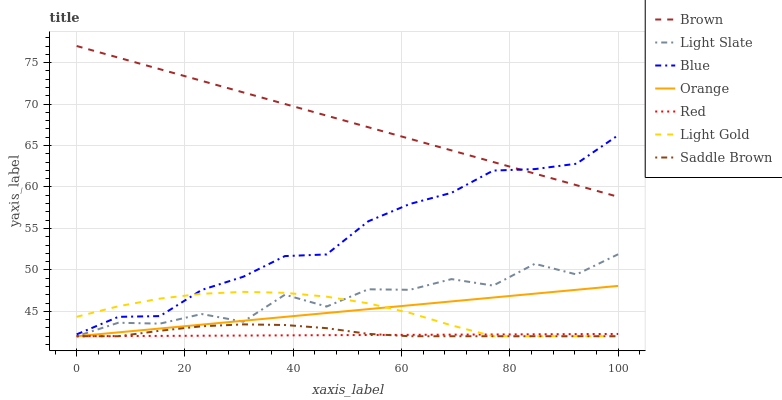Does Light Slate have the minimum area under the curve?
Answer yes or no. No. Does Light Slate have the maximum area under the curve?
Answer yes or no. No. Is Brown the smoothest?
Answer yes or no. No. Is Brown the roughest?
Answer yes or no. No. Does Brown have the lowest value?
Answer yes or no. No. Does Light Slate have the highest value?
Answer yes or no. No. Is Light Slate less than Brown?
Answer yes or no. Yes. Is Brown greater than Light Gold?
Answer yes or no. Yes. Does Light Slate intersect Brown?
Answer yes or no. No. 